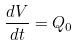Convert formula to latex. <formula><loc_0><loc_0><loc_500><loc_500>\frac { d V } { d t } = Q _ { 0 }</formula> 